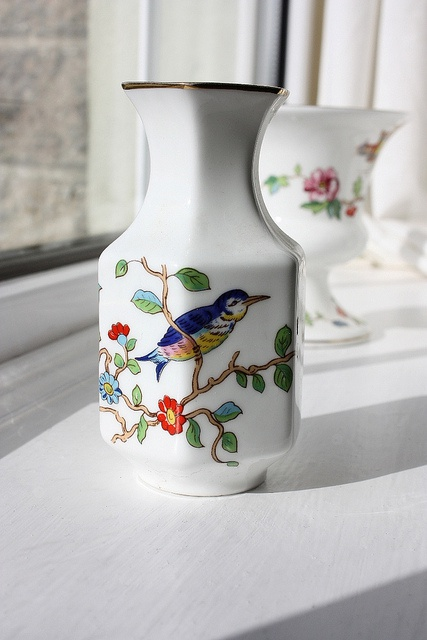Describe the objects in this image and their specific colors. I can see vase in darkgray, lightgray, gray, and black tones, vase in darkgray, lightgray, and gray tones, and bird in darkgray, black, navy, gray, and olive tones in this image. 